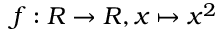<formula> <loc_0><loc_0><loc_500><loc_500>f \colon R \rightarrow R , x \mapsto x ^ { 2 }</formula> 